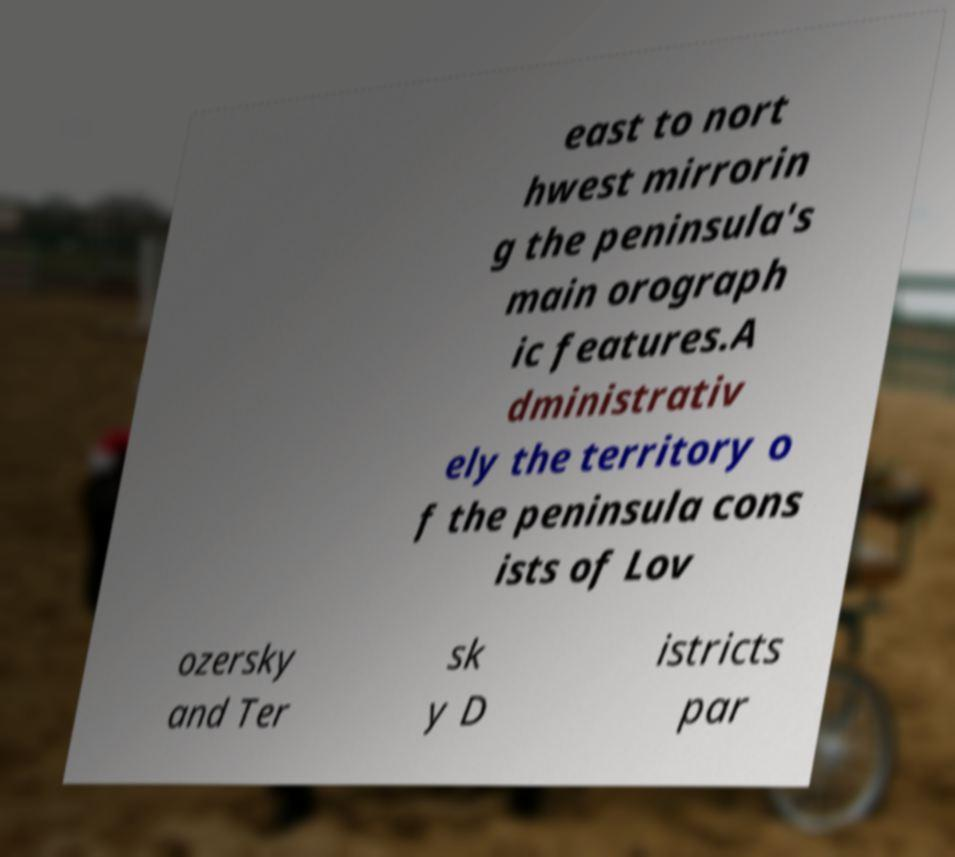Please read and relay the text visible in this image. What does it say? east to nort hwest mirrorin g the peninsula's main orograph ic features.A dministrativ ely the territory o f the peninsula cons ists of Lov ozersky and Ter sk y D istricts par 